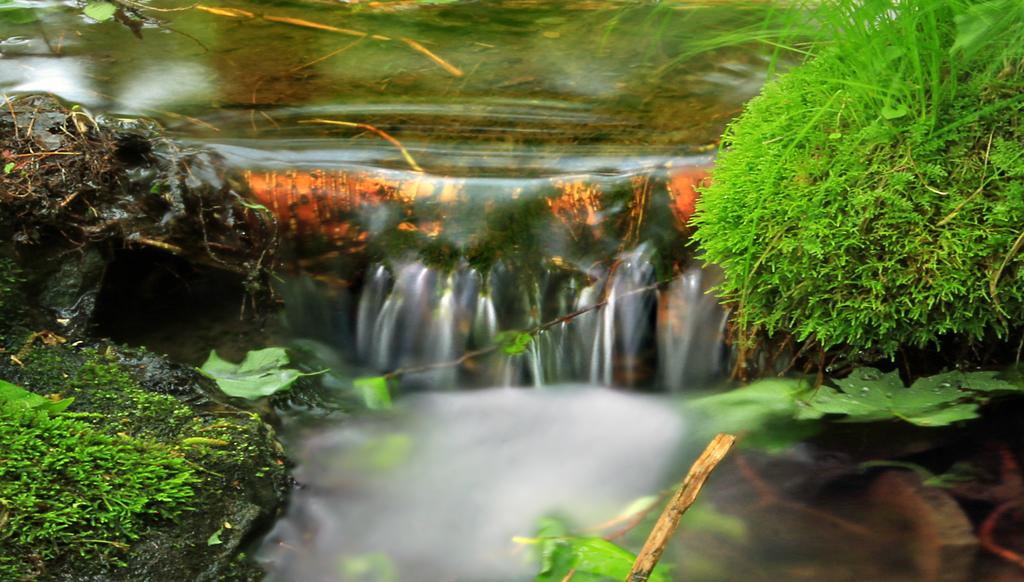What is happening in the image? There is water flow in the image. Where are the plants located in the image? There is a group of plants on the right side of the image. What statement is being made by the meat in the image? There is no meat present in the image, so no statement can be made by it. 